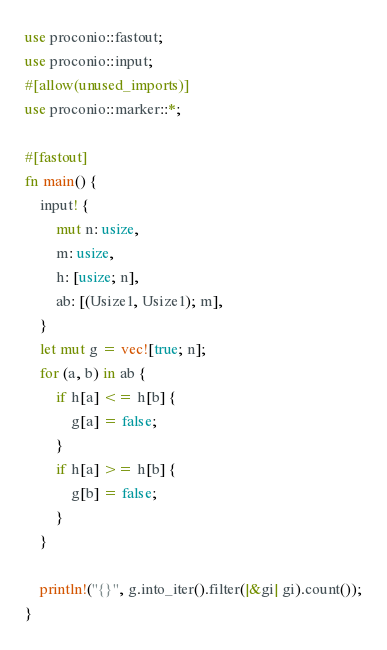<code> <loc_0><loc_0><loc_500><loc_500><_Rust_>use proconio::fastout;
use proconio::input;
#[allow(unused_imports)]
use proconio::marker::*;

#[fastout]
fn main() {
    input! {
        mut n: usize,
        m: usize,
        h: [usize; n],
        ab: [(Usize1, Usize1); m],
    }
    let mut g = vec![true; n];
    for (a, b) in ab {
        if h[a] <= h[b] {
            g[a] = false;
        }
        if h[a] >= h[b] {
            g[b] = false;
        }
    }

    println!("{}", g.into_iter().filter(|&gi| gi).count());
}
</code> 